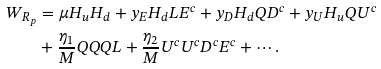Convert formula to latex. <formula><loc_0><loc_0><loc_500><loc_500>W _ { R _ { p } } & = \mu H _ { u } H _ { d } + y _ { E } H _ { d } L E ^ { c } + y _ { D } H _ { d } Q D ^ { c } + y _ { U } H _ { u } Q U ^ { c } \\ & + \frac { \eta _ { 1 } } { M } Q Q Q L + \frac { \eta _ { 2 } } { M } U ^ { c } U ^ { c } D ^ { c } E ^ { c } + \cdots .</formula> 